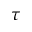Convert formula to latex. <formula><loc_0><loc_0><loc_500><loc_500>\tau</formula> 